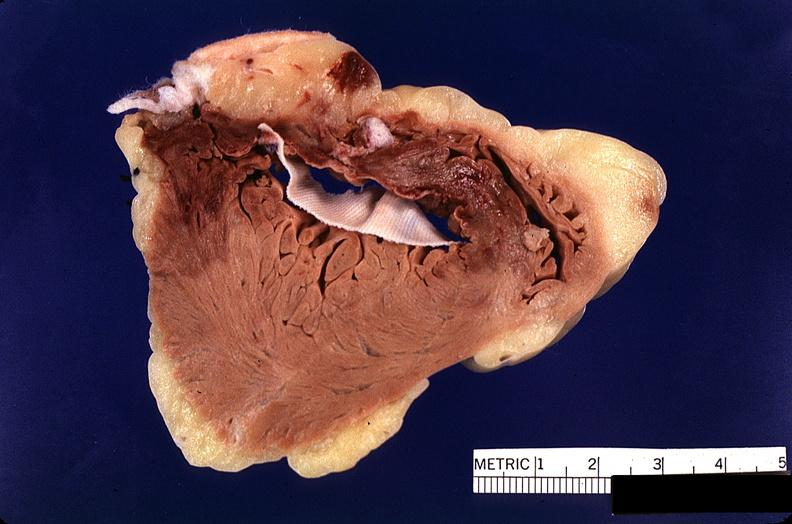s cardiovascular present?
Answer the question using a single word or phrase. Yes 